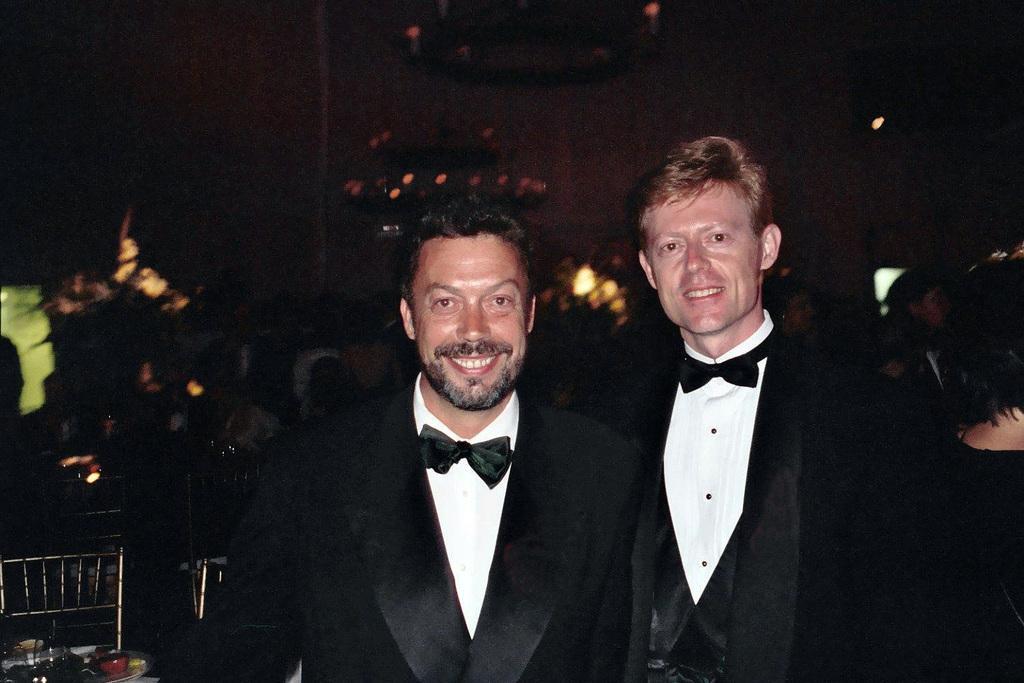How would you summarize this image in a sentence or two? In the image to the front there is a man with black jacket and white shirt is standing and he is smiling. Beside him to the right side there is a man with black jacket and white shirt is standing and he is smiling. To the bottom left corner of the image there is a chair. In front of the chair there are few things. 